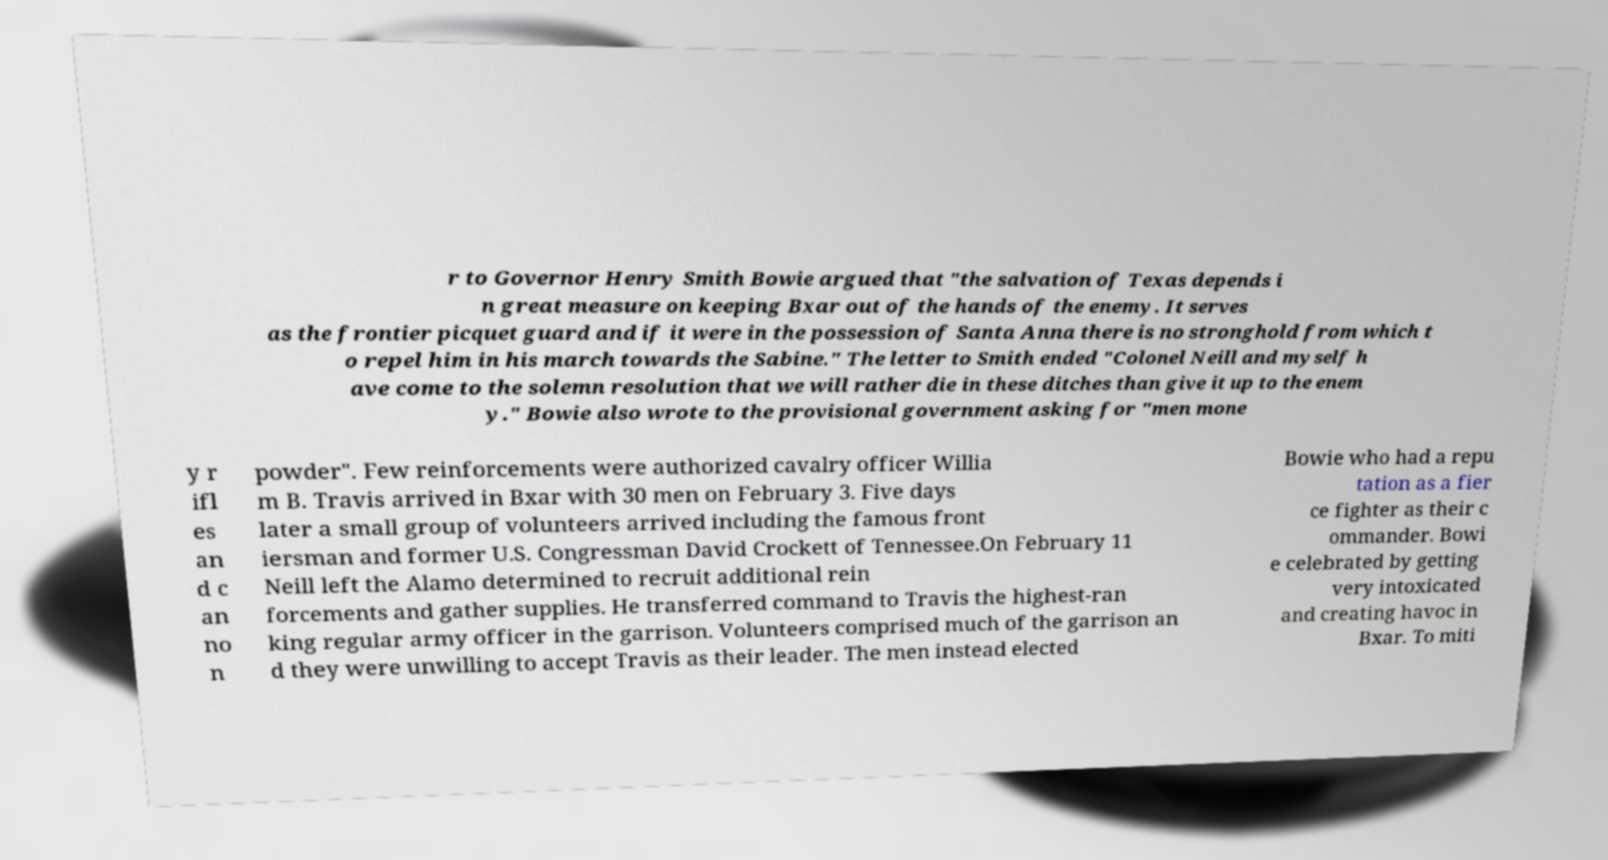I need the written content from this picture converted into text. Can you do that? r to Governor Henry Smith Bowie argued that "the salvation of Texas depends i n great measure on keeping Bxar out of the hands of the enemy. It serves as the frontier picquet guard and if it were in the possession of Santa Anna there is no stronghold from which t o repel him in his march towards the Sabine." The letter to Smith ended "Colonel Neill and myself h ave come to the solemn resolution that we will rather die in these ditches than give it up to the enem y." Bowie also wrote to the provisional government asking for "men mone y r ifl es an d c an no n powder". Few reinforcements were authorized cavalry officer Willia m B. Travis arrived in Bxar with 30 men on February 3. Five days later a small group of volunteers arrived including the famous front iersman and former U.S. Congressman David Crockett of Tennessee.On February 11 Neill left the Alamo determined to recruit additional rein forcements and gather supplies. He transferred command to Travis the highest-ran king regular army officer in the garrison. Volunteers comprised much of the garrison an d they were unwilling to accept Travis as their leader. The men instead elected Bowie who had a repu tation as a fier ce fighter as their c ommander. Bowi e celebrated by getting very intoxicated and creating havoc in Bxar. To miti 